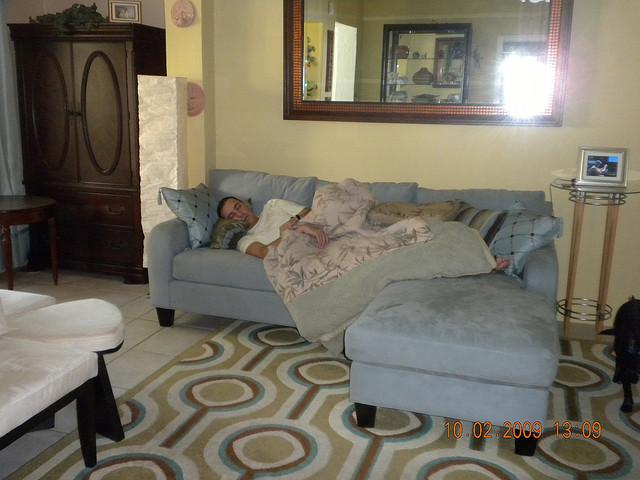Which room is this?
Write a very short answer. Living room. What room is this?
Short answer required. Living room. What is on the floor?
Write a very short answer. Rug. Is there a reflection in the mirror?
Concise answer only. Yes. 